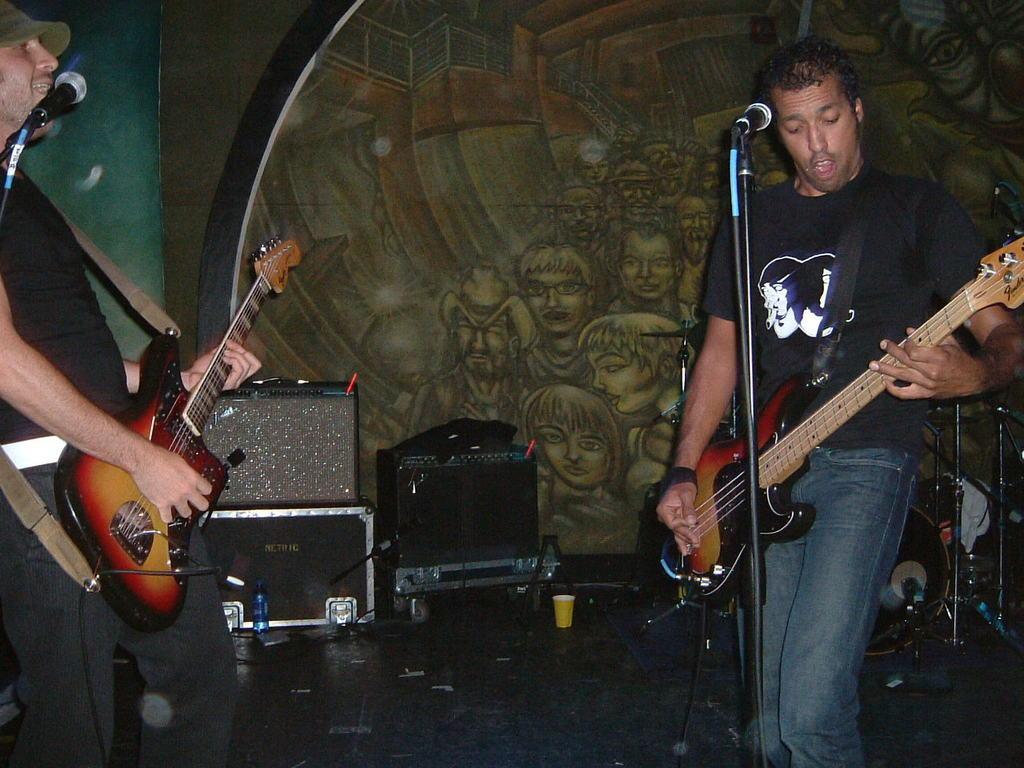Could you give a brief overview of what you see in this image? In this picture we can see two people standing holding guitars in their hand and playing and singing on mic and in background we can see wall with painting, speakers, bottle, glass. 